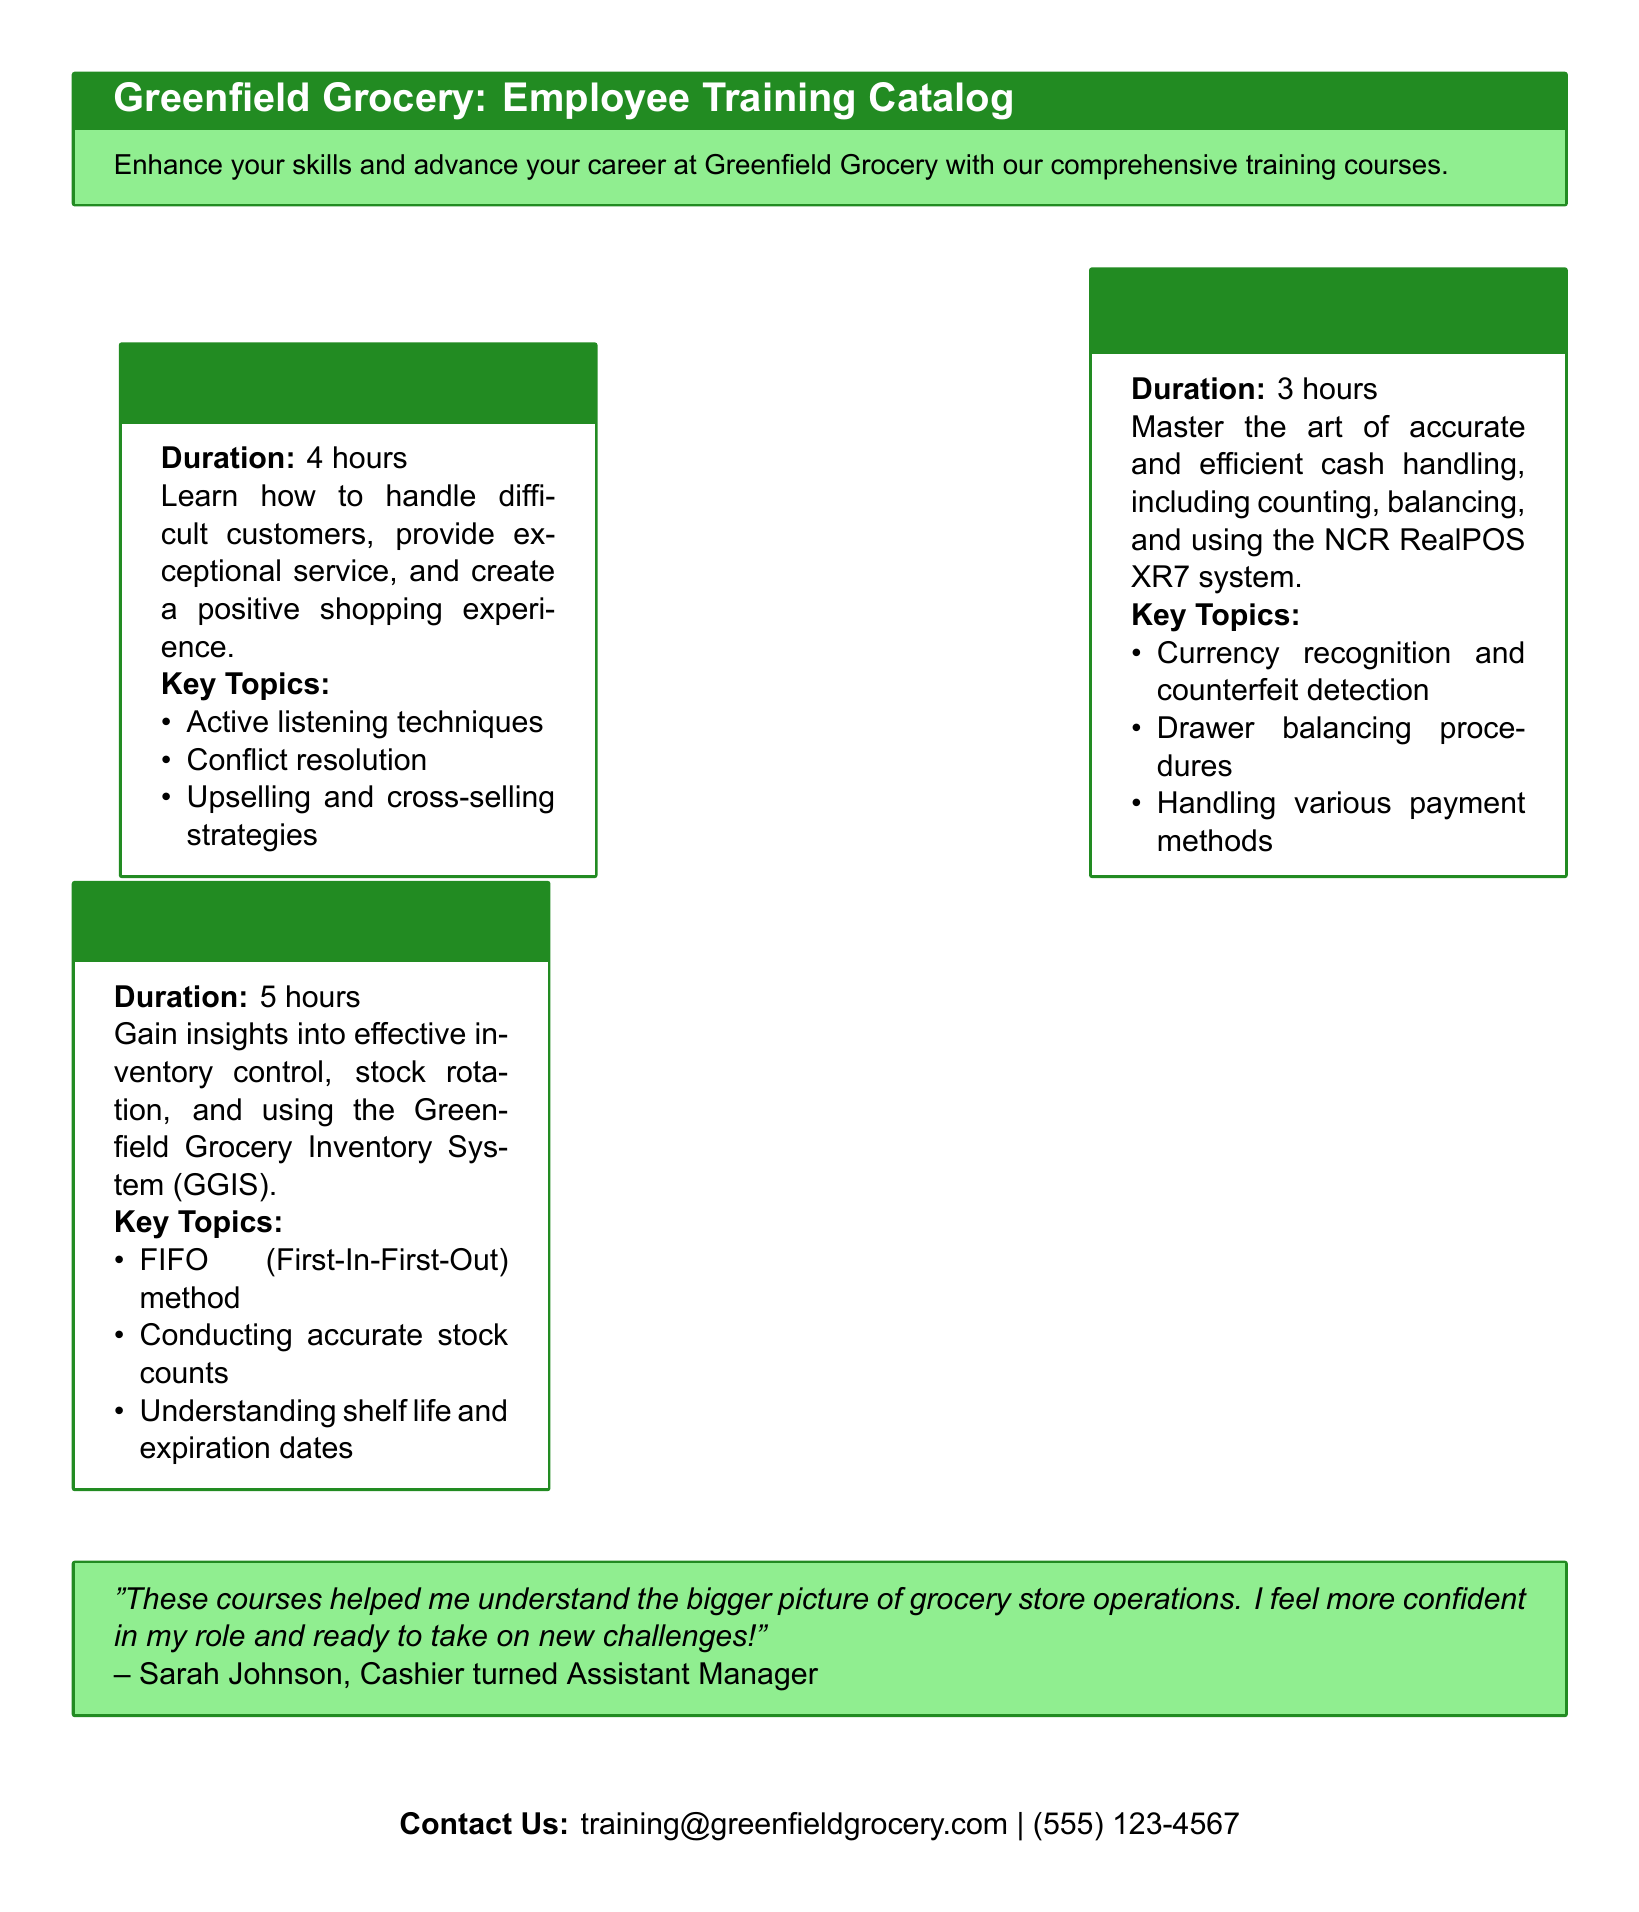What is the duration of the Customer Service Excellence course? The duration is mentioned in the course section, which is 4 hours.
Answer: 4 hours What is the main focus of the Cash Handling and Register Operations course? The main focus is stated as mastering accurate and efficient cash handling, including various aspects of register operations.
Answer: Accurate and efficient cash handling Which inventory management method is taught in the Inventory Management Fundamentals course? The course mentions the FIFO (First-In-First-Out) method as a key topic.
Answer: FIFO (First-In-First-Out) How many hours is the Inventory Management Fundamentals course? The duration specified in the document for this course is 5 hours.
Answer: 5 hours What is the contact email for training inquiries? The document provides the contact email at the bottom, which is training@greenfieldgrocery.com.
Answer: training@greenfieldgrocery.com What quote does Sarah Johnson provide about the training courses? The quote reflects her positive experience and confidence gained from the courses.
Answer: "These courses helped me understand the bigger picture of grocery store operations." What payment methods are mentioned in the Cash Handling course? The document mentions handling various payment methods as a key topic.
Answer: Various payment methods What is one of the key topics in the Customer Service Excellence course? The document lists active listening techniques as one of the key topics in that course.
Answer: Active listening techniques 